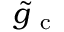<formula> <loc_0><loc_0><loc_500><loc_500>\tilde { g } _ { c }</formula> 